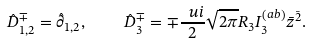Convert formula to latex. <formula><loc_0><loc_0><loc_500><loc_500>\hat { D } _ { 1 , 2 } ^ { \mp } = \hat { \partial } _ { 1 , 2 } , \quad \hat { D } _ { 3 } ^ { \mp } = \mp \frac { \ u i } { 2 } \sqrt { 2 \pi } R _ { 3 } I _ { 3 } ^ { \left ( a b \right ) } \bar { z } ^ { \bar { 2 } } .</formula> 